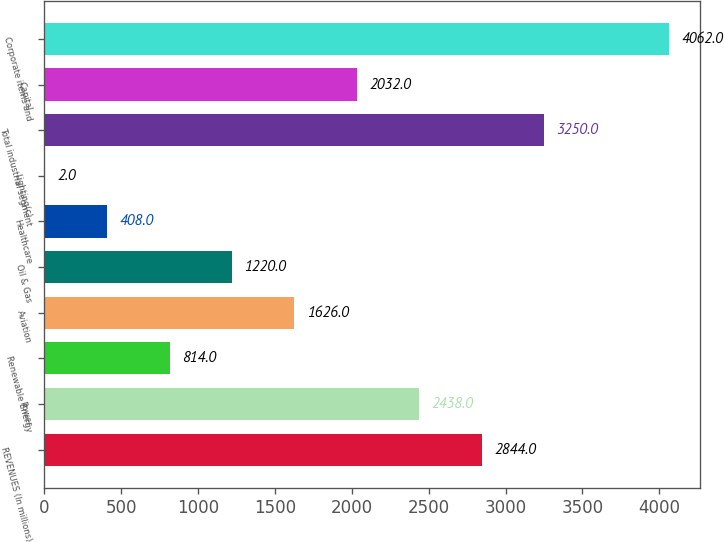Convert chart to OTSL. <chart><loc_0><loc_0><loc_500><loc_500><bar_chart><fcel>REVENUES (In millions)<fcel>Power<fcel>Renewable Energy<fcel>Aviation<fcel>Oil & Gas<fcel>Healthcare<fcel>Lighting(c)<fcel>Total industrial segment<fcel>Capital<fcel>Corporate items and<nl><fcel>2844<fcel>2438<fcel>814<fcel>1626<fcel>1220<fcel>408<fcel>2<fcel>3250<fcel>2032<fcel>4062<nl></chart> 